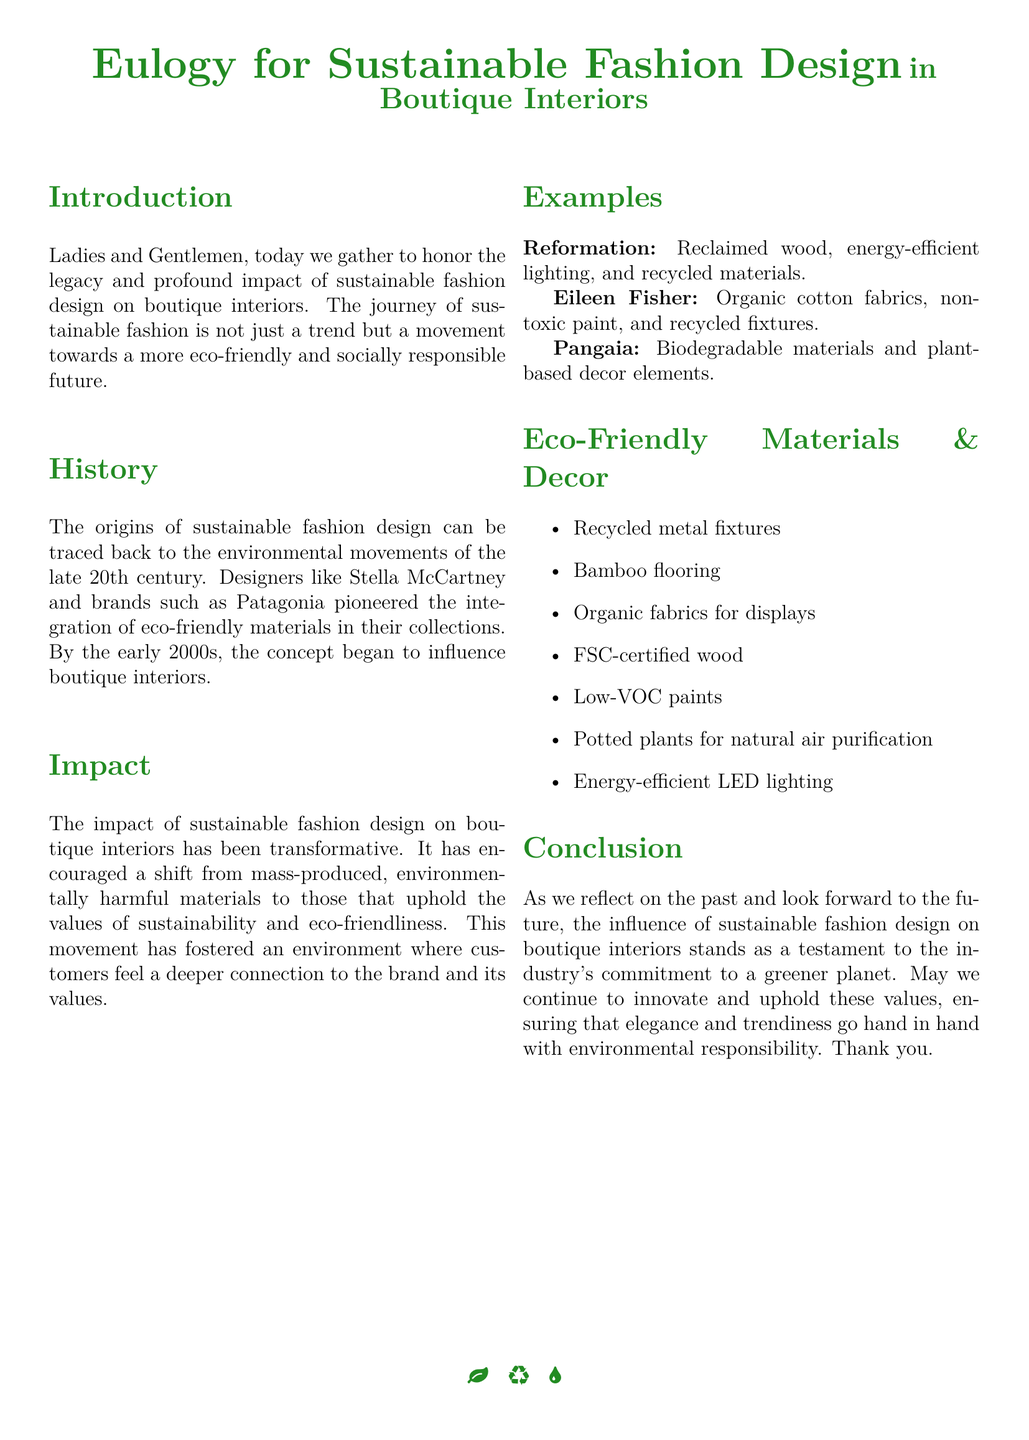What is the main theme of the eulogy? The main theme of the eulogy focuses on the legacy and impact of sustainable fashion design in boutique interiors.
Answer: sustainable fashion design Who are two pioneering designers mentioned in the document? The document mentions Stella McCartney and the brand Patagonia as pioneers in sustainable fashion.
Answer: Stella McCartney, Patagonia In which decade did sustainable fashion design origins trace back? The origins of sustainable fashion design can be traced back to the late 20th century.
Answer: late 20th century What material is used by Reformation for decor? Reformation uses reclaimed wood as one of its eco-friendly materials for decor.
Answer: reclaimed wood Name one eco-friendly flooring option listed. Bamboo flooring is mentioned as an eco-friendly flooring option in the document.
Answer: Bamboo flooring Which brand utilizes biodegradable materials? The brand Pangaia is noted for utilizing biodegradable materials in its designs.
Answer: Pangaia What type of paint is recommended in the eco-friendly materials section? Low-VOC paints are recommended in the eco-friendly materials section of the eulogy.
Answer: Low-VOC paints What overall commitment does the eulogy emphasize? The eulogy emphasizes the industry's commitment to a greener planet through sustainable practices.
Answer: a greener planet 